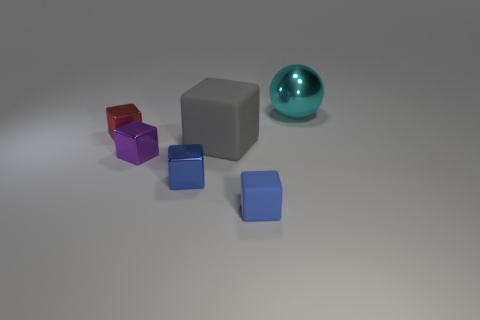Subtract all gray blocks. How many blocks are left? 4 Add 4 large brown matte objects. How many objects exist? 10 Subtract all blue balls. How many blue cubes are left? 2 Subtract 1 blocks. How many blocks are left? 4 Subtract all purple cubes. How many cubes are left? 4 Add 5 tiny cyan matte cylinders. How many tiny cyan matte cylinders exist? 5 Subtract 0 purple balls. How many objects are left? 6 Subtract all blocks. How many objects are left? 1 Subtract all green blocks. Subtract all green spheres. How many blocks are left? 5 Subtract all purple metallic cubes. Subtract all tiny metal blocks. How many objects are left? 2 